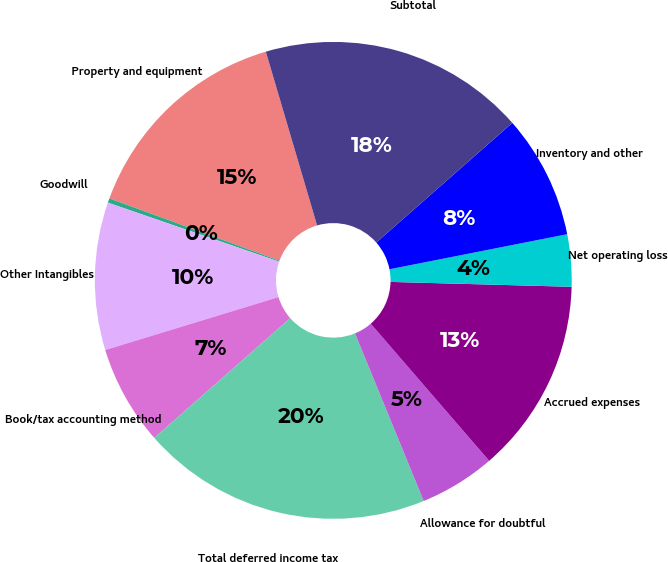Convert chart. <chart><loc_0><loc_0><loc_500><loc_500><pie_chart><fcel>Property and equipment<fcel>Goodwill<fcel>Other Intangibles<fcel>Book/tax accounting method<fcel>Total deferred income tax<fcel>Allowance for doubtful<fcel>Accrued expenses<fcel>Net operating loss<fcel>Inventory and other<fcel>Subtotal<nl><fcel>14.85%<fcel>0.3%<fcel>10.0%<fcel>6.77%<fcel>19.7%<fcel>5.15%<fcel>13.23%<fcel>3.53%<fcel>8.38%<fcel>18.08%<nl></chart> 